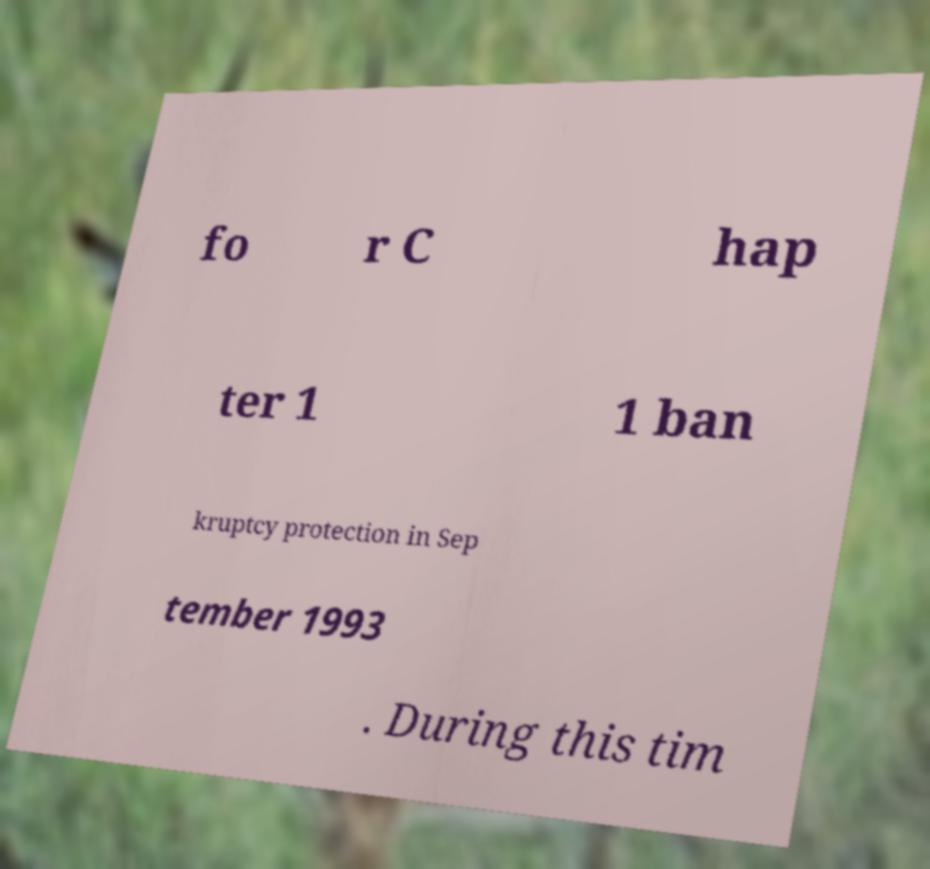What messages or text are displayed in this image? I need them in a readable, typed format. fo r C hap ter 1 1 ban kruptcy protection in Sep tember 1993 . During this tim 